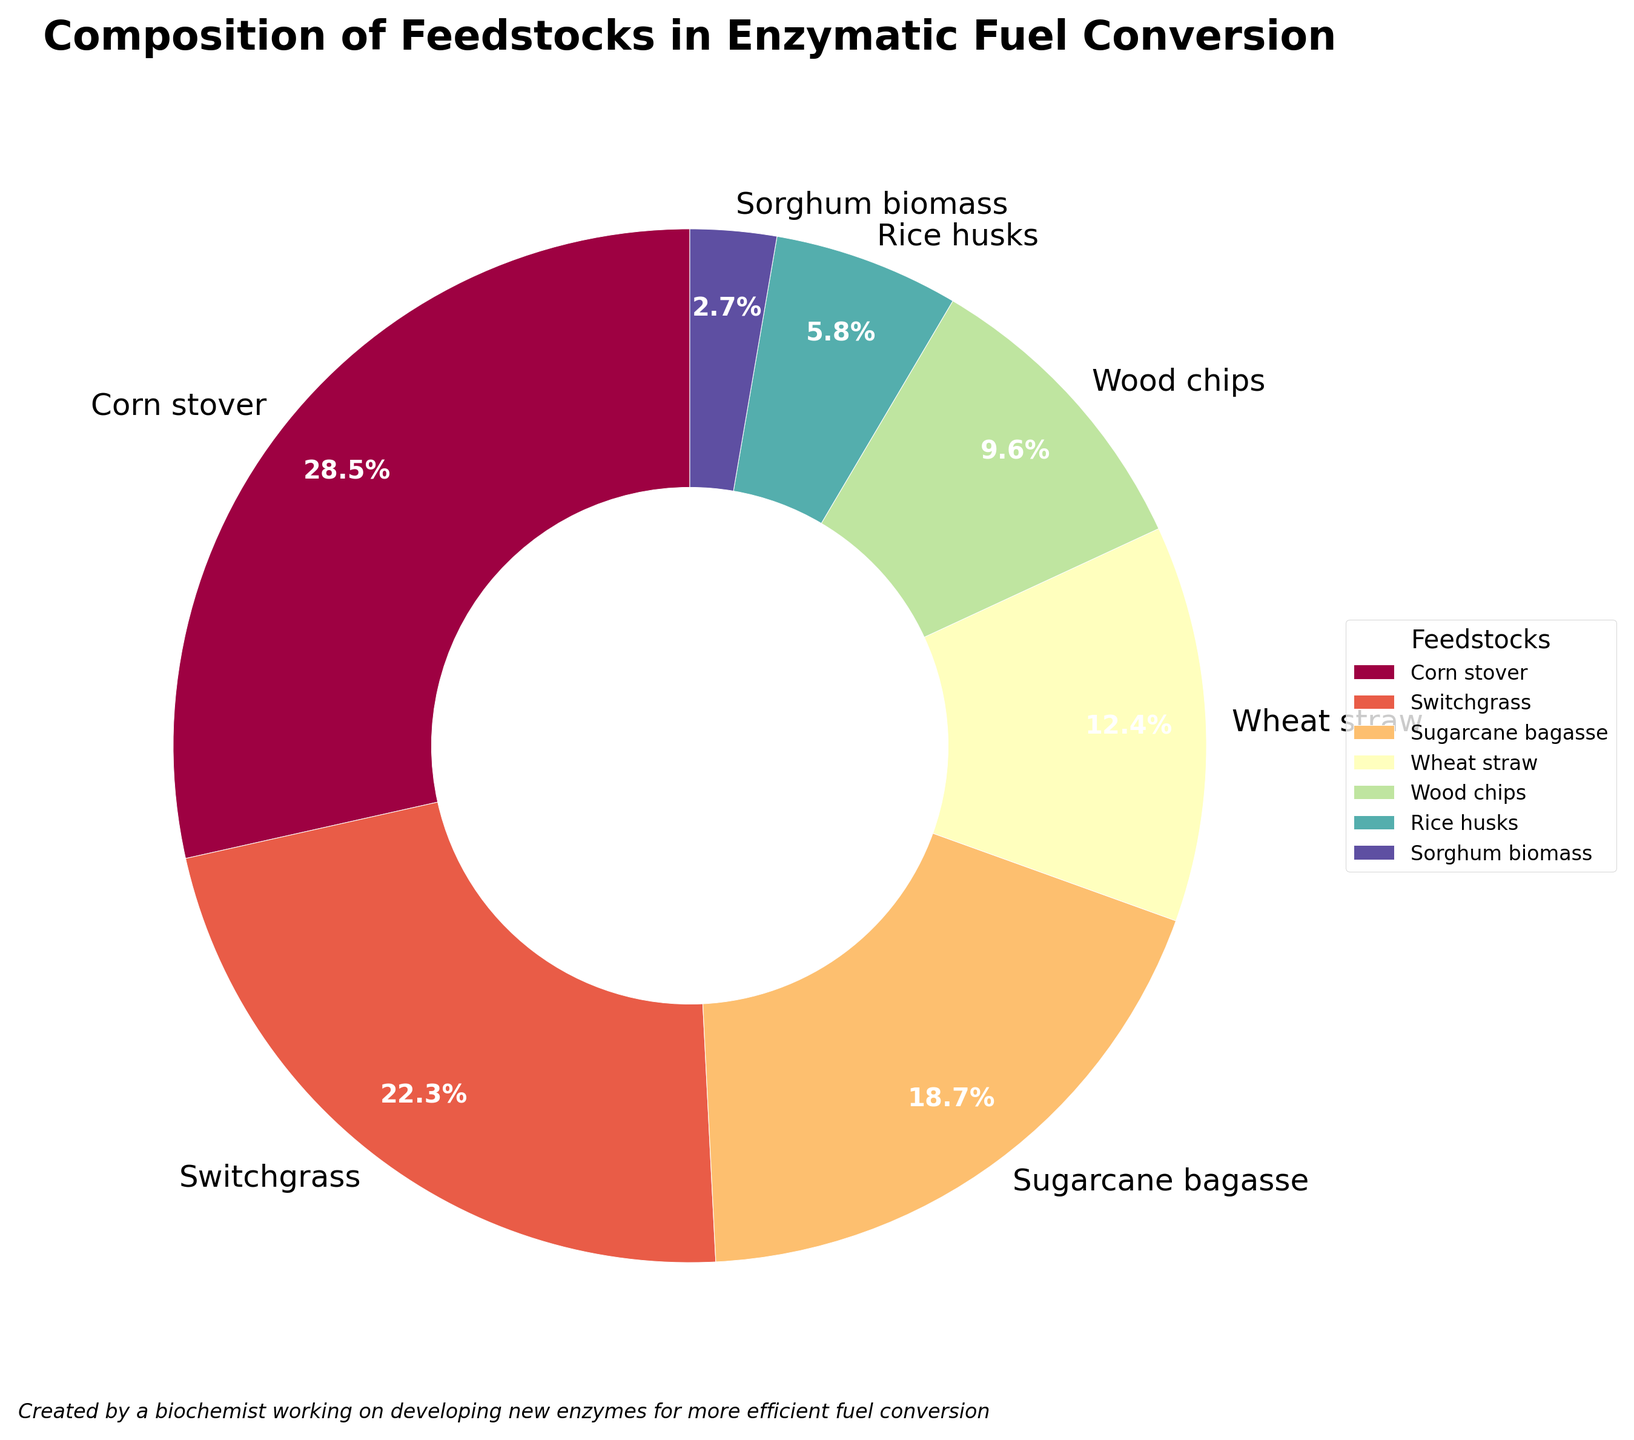What percentage of feedstocks is comprised of Corn stover and Switchgrass combined? To answer this, we add the percentage of Corn stover, which is 28.5%, and the percentage of Switchgrass, which is 22.3%. So, 28.5 + 22.3 = 50.8%.
Answer: 50.8% What is the difference in percentage between the most and least abundant feedstocks? The most abundant feedstock is Corn stover at 28.5%, and the least abundant is Sorghum biomass at 2.7%. The difference is 28.5 - 2.7 = 25.8%.
Answer: 25.8% Which feedstock represents the third largest portion of the composition? From the data, Corn stover is the largest portion, followed by Switchgrass, and then Sugarcane bagasse. Therefore, the third largest portion is Sugarcane bagasse.
Answer: Sugarcane bagasse Are Wheat straw and Wood chips combined more or less than Switchgrass in terms of percentage? Wheat straw is 12.4% and Wood chips are 9.6%. Together, they make 12.4 + 9.6 = 22.0%. Switchgrass alone is 22.3%, so they are less than Switchgrass.
Answer: Less Which feedstock is depicted with the color near the middle of the spectrum? The 'Spectral' colormap varies from blue to red through green and yellow. Switchgrass is in the middle of the spectrum.
Answer: Switchgrass What is the cumulative percentage of all feedstocks other than Corn stover? We sum the percentages of all feedstocks except Corn stover: 22.3 (Switchgrass) + 18.7 (Sugarcane bagasse) + 12.4 (Wheat straw) + 9.6 (Wood chips) + 5.8 (Rice husks) + 2.7 (Sorghum biomass) = 71.5%.
Answer: 71.5% How much larger in percentage is Switchgrass compared to Sorghum biomass? Switchgrass is 22.3%, and Sorghum biomass is 2.7%. The difference is 22.3 - 2.7 = 19.6%.
Answer: 19.6% What are the feedstocks with a percentage below 10% each? From the data, Wood chips (9.6%), Rice husks (5.8%), and Sorghum biomass (2.7%) are all below 10%.
Answer: Wood chips, Rice husks, Sorghum biomass 